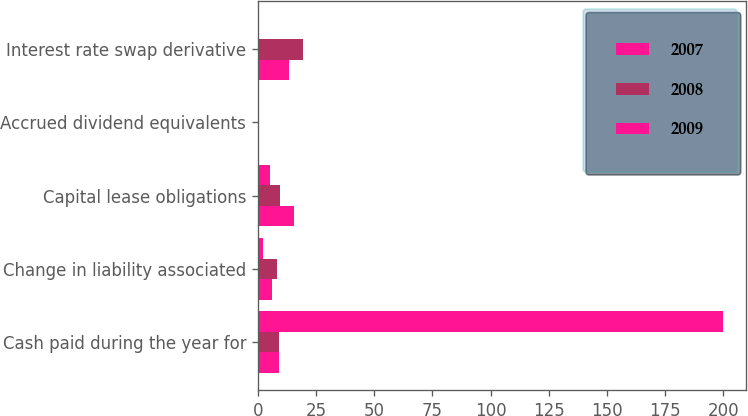Convert chart to OTSL. <chart><loc_0><loc_0><loc_500><loc_500><stacked_bar_chart><ecel><fcel>Cash paid during the year for<fcel>Change in liability associated<fcel>Capital lease obligations<fcel>Accrued dividend equivalents<fcel>Interest rate swap derivative<nl><fcel>2007<fcel>9<fcel>5.9<fcel>15.5<fcel>0.1<fcel>13.6<nl><fcel>2008<fcel>9<fcel>8.3<fcel>9.7<fcel>0.2<fcel>19.5<nl><fcel>2009<fcel>199.6<fcel>2.1<fcel>5.1<fcel>0.2<fcel>0.6<nl></chart> 